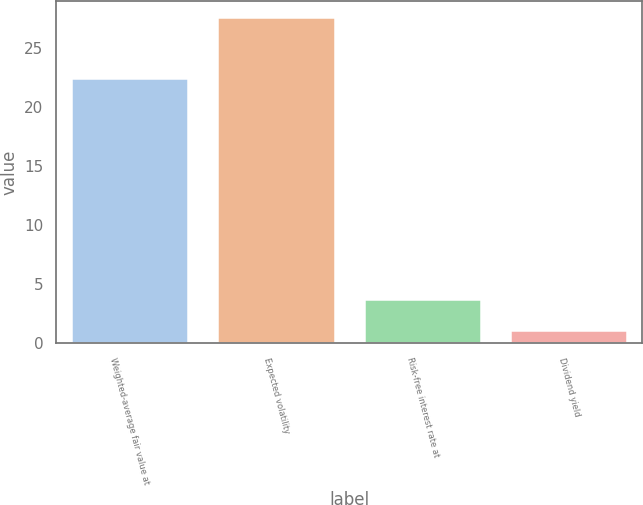<chart> <loc_0><loc_0><loc_500><loc_500><bar_chart><fcel>Weighted-average fair value at<fcel>Expected volatility<fcel>Risk-free interest rate at<fcel>Dividend yield<nl><fcel>22.45<fcel>27.6<fcel>3.75<fcel>1.1<nl></chart> 